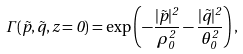Convert formula to latex. <formula><loc_0><loc_0><loc_500><loc_500>\Gamma ( \vec { p } , \vec { q } , z = 0 ) = \exp \left ( - \frac { | \vec { p } | ^ { 2 } } { \rho _ { 0 } ^ { 2 } } - \frac { | \vec { q } | ^ { 2 } } { \theta _ { 0 } ^ { 2 } } \right ) ,</formula> 